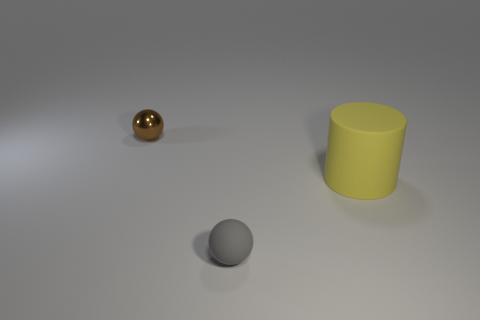Add 3 yellow cylinders. How many objects exist? 6 Subtract all cylinders. How many objects are left? 2 Add 3 shiny things. How many shiny things are left? 4 Add 1 small balls. How many small balls exist? 3 Subtract 0 brown cubes. How many objects are left? 3 Subtract all big rubber things. Subtract all purple metal cubes. How many objects are left? 2 